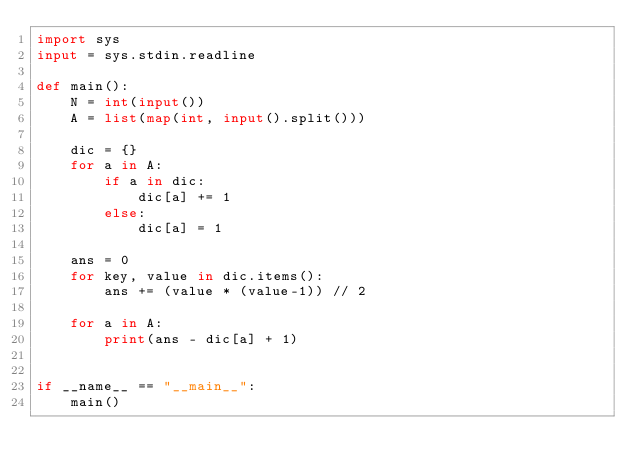<code> <loc_0><loc_0><loc_500><loc_500><_Python_>import sys
input = sys.stdin.readline

def main():
    N = int(input())
    A = list(map(int, input().split()))

    dic = {}
    for a in A:
        if a in dic:
            dic[a] += 1
        else:
            dic[a] = 1
    
    ans = 0
    for key, value in dic.items():
        ans += (value * (value-1)) // 2
    
    for a in A:
        print(ans - dic[a] + 1)


if __name__ == "__main__":
    main()</code> 